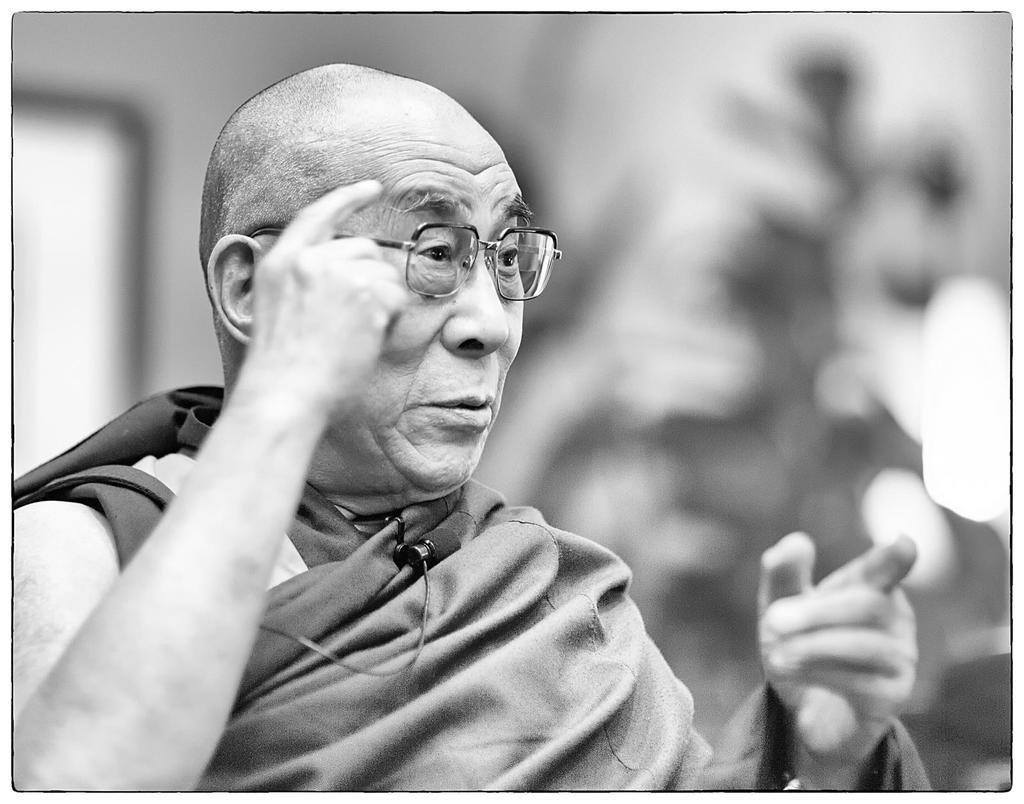What is the color scheme of the image? The image is black and white. Who is present in the image? There is a man in the image. What is the man wearing in the image? The man is wearing spectacles in the image. What else can be seen in the image besides the man? There is a wire in the image. How is the wire depicted in the image? The wire is blurred in the background. What type of division is visible in the image? There is no division present in the image; it is a black and white photograph featuring a man and a blurred wire. 